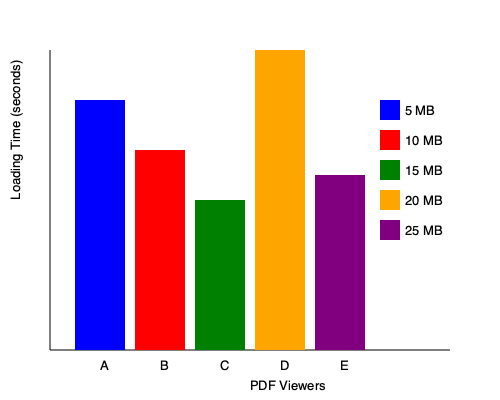Based on the bar chart comparing PDF file sizes and their loading times in various viewers, which viewer (A, B, C, D, or E) demonstrates the best performance for larger file sizes, specifically for the 25 MB PDF file? To determine which PDF viewer performs best for larger file sizes, particularly the 25 MB file, we need to analyze the chart step-by-step:

1. Identify the bar representing the 25 MB file:
   - The purple bar represents the 25 MB file size.

2. Compare the heights of the purple bars across all viewers:
   - Viewer A: Highest purple bar
   - Viewer B: Second highest purple bar
   - Viewer C: Third highest purple bar
   - Viewer D: Highest overall bar (orange, representing 20 MB)
   - Viewer E: Lowest purple bar

3. Interpret the bar heights:
   - Lower bar height indicates faster loading time.
   - Higher bar height indicates slower loading time.

4. Analyze the performance for the 25 MB file:
   - Viewer E has the lowest purple bar, indicating the fastest loading time for the 25 MB file.

5. Consider overall performance:
   - While Viewer E performs best for the 25 MB file, it's worth noting that Viewer C shows consistent performance across all file sizes.
   - Viewer D struggles with larger file sizes, as evidenced by its highest bar for the 20 MB file.

6. Conclusion:
   - For the specific question about the 25 MB file, Viewer E demonstrates the best performance.
Answer: Viewer E 